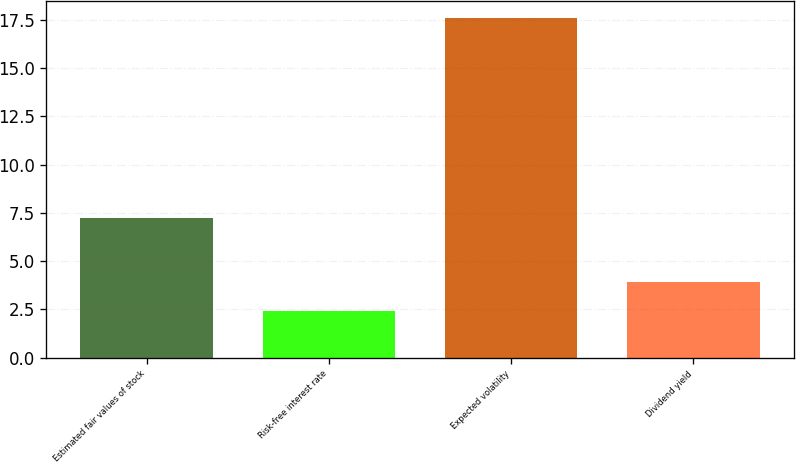<chart> <loc_0><loc_0><loc_500><loc_500><bar_chart><fcel>Estimated fair values of stock<fcel>Risk-free interest rate<fcel>Expected volatility<fcel>Dividend yield<nl><fcel>7.24<fcel>2.4<fcel>17.6<fcel>3.92<nl></chart> 